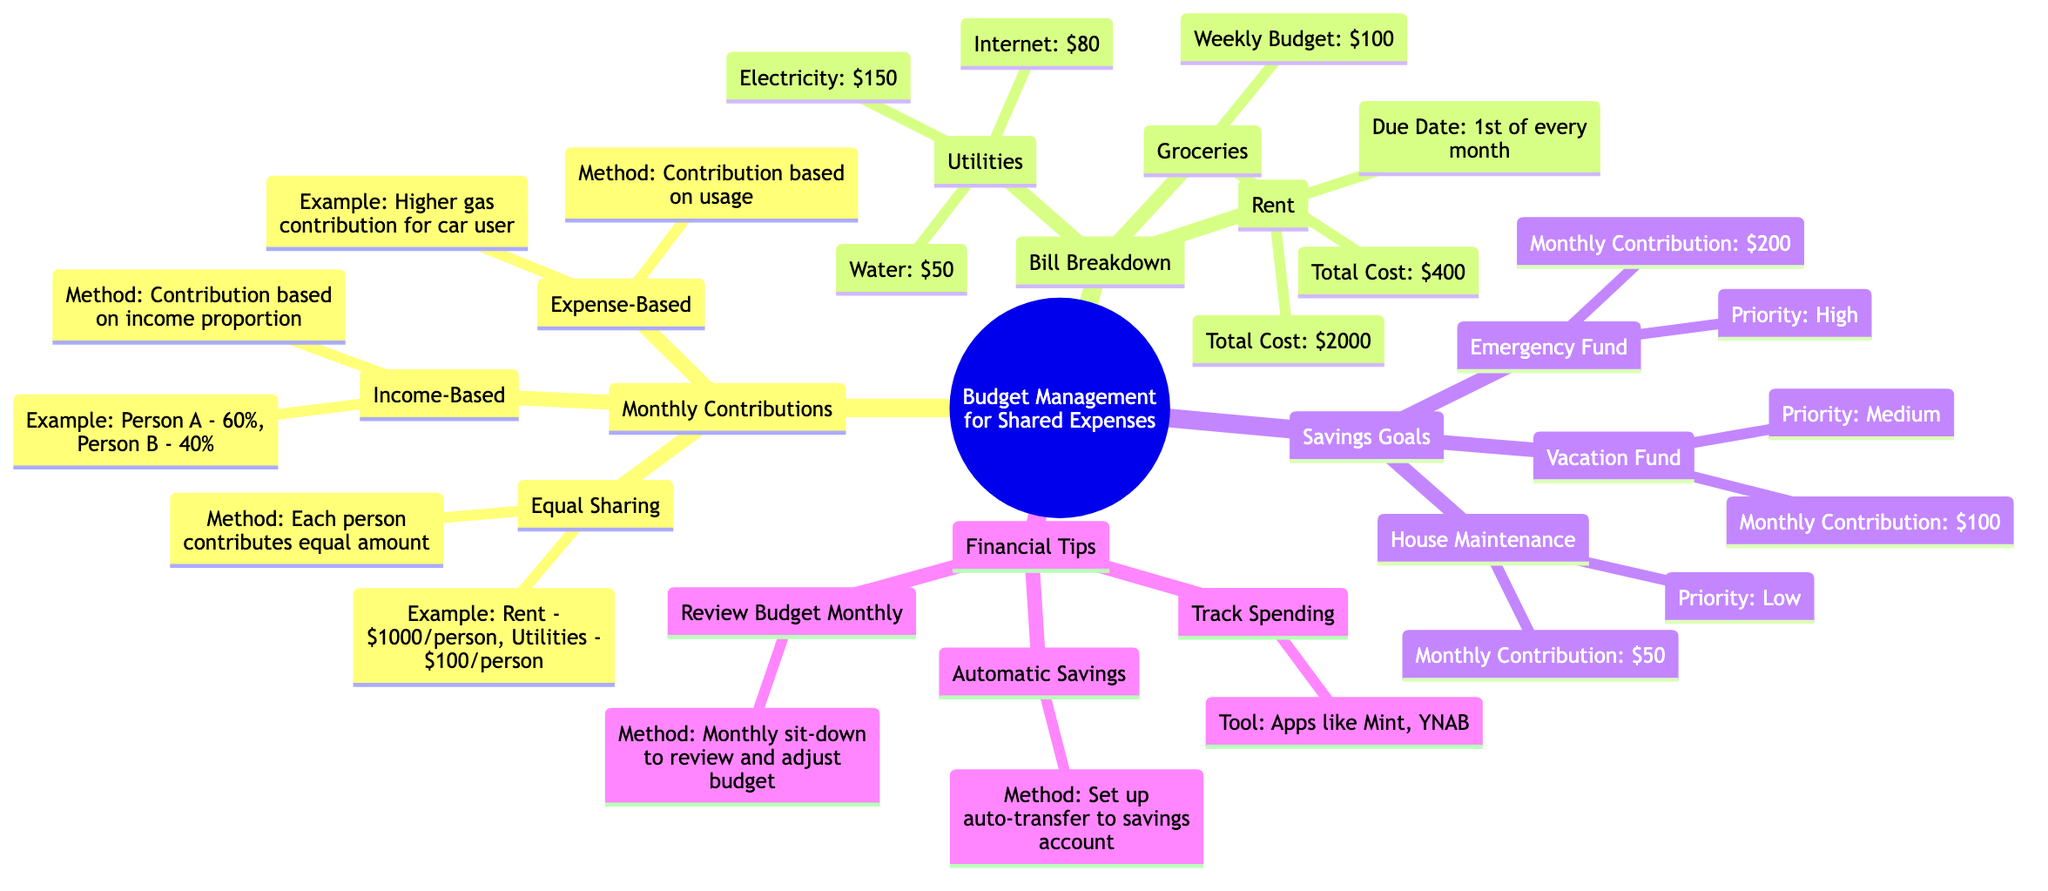What is the total cost for rent? The diagram states the total cost of rent is listed under "Rent" in the "Bill Breakdown" section. It specifies the total cost as "$2000."
Answer: $2000 When is the rent due? The due date for rent is also found in the "Bill Breakdown" section under "Rent." It indicates that the rent is due on the "1st of every month."
Answer: 1st of every month How much is the monthly contribution for the emergency fund? The monthly contribution for the emergency fund can be found in the "Savings Goals" section, under "Emergency Fund," which states that the contribution is "$200."
Answer: $200 What method is used for equal sharing contributions? The method for equal sharing is listed under "Monthly Contributions" in the "Equal Sharing" subsection. It specifies that the method is "Each person contributes equal amount."
Answer: Each person contributes equal amount What is the monthly contribution for the vacation fund compared to the house maintenance fund? To determine the differences, look in the "Savings Goals" section. The monthly contribution for the vacation fund is "$100," while for house maintenance, it is "$50." This indicates the vacation fund has a higher contribution.
Answer: $100 vs. $50 What tools are suggested for tracking spending? The "Financial Tips" section under "Track Spending" mentions tools for tracking spending as "Apps like Mint, YNAB."
Answer: Apps like Mint, YNAB Which expense type has the highest monthly breakdown? Analyzing the expenses listed, we see "Rent" totals $2000, while other expenses have smaller totals. Therefore, rent has the highest breakdown in the diagram.
Answer: Rent Which savings goal has the lowest priority? In the "Savings Goals" section, each goal is categorized by priority. The "House Maintenance" goal is listed as having a "Low" priority, making it the lowest in that category.
Answer: Low How much is suggested as the automatic savings contribution method? The "Financial Tips" section mentions that the automatic savings method is to "Set up auto-transfer to savings account." While it doesn't specify an amount, it indicates a method rather than a financial figure.
Answer: Set up auto-transfer to savings account 